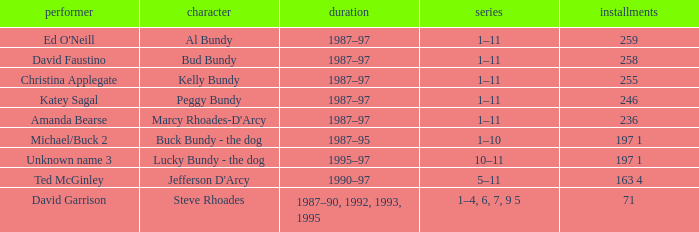How many episodes did the actor David Faustino appear in? 258.0. 